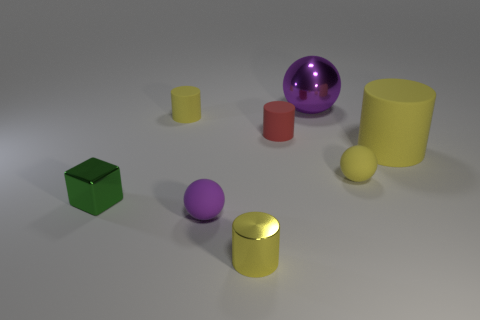Subtract all yellow cubes. How many yellow cylinders are left? 3 Add 1 small purple rubber things. How many objects exist? 9 Subtract all cyan cylinders. Subtract all cyan blocks. How many cylinders are left? 4 Subtract all spheres. How many objects are left? 5 Add 4 yellow cylinders. How many yellow cylinders exist? 7 Subtract 1 green cubes. How many objects are left? 7 Subtract all small balls. Subtract all purple shiny spheres. How many objects are left? 5 Add 1 tiny green metal cubes. How many tiny green metal cubes are left? 2 